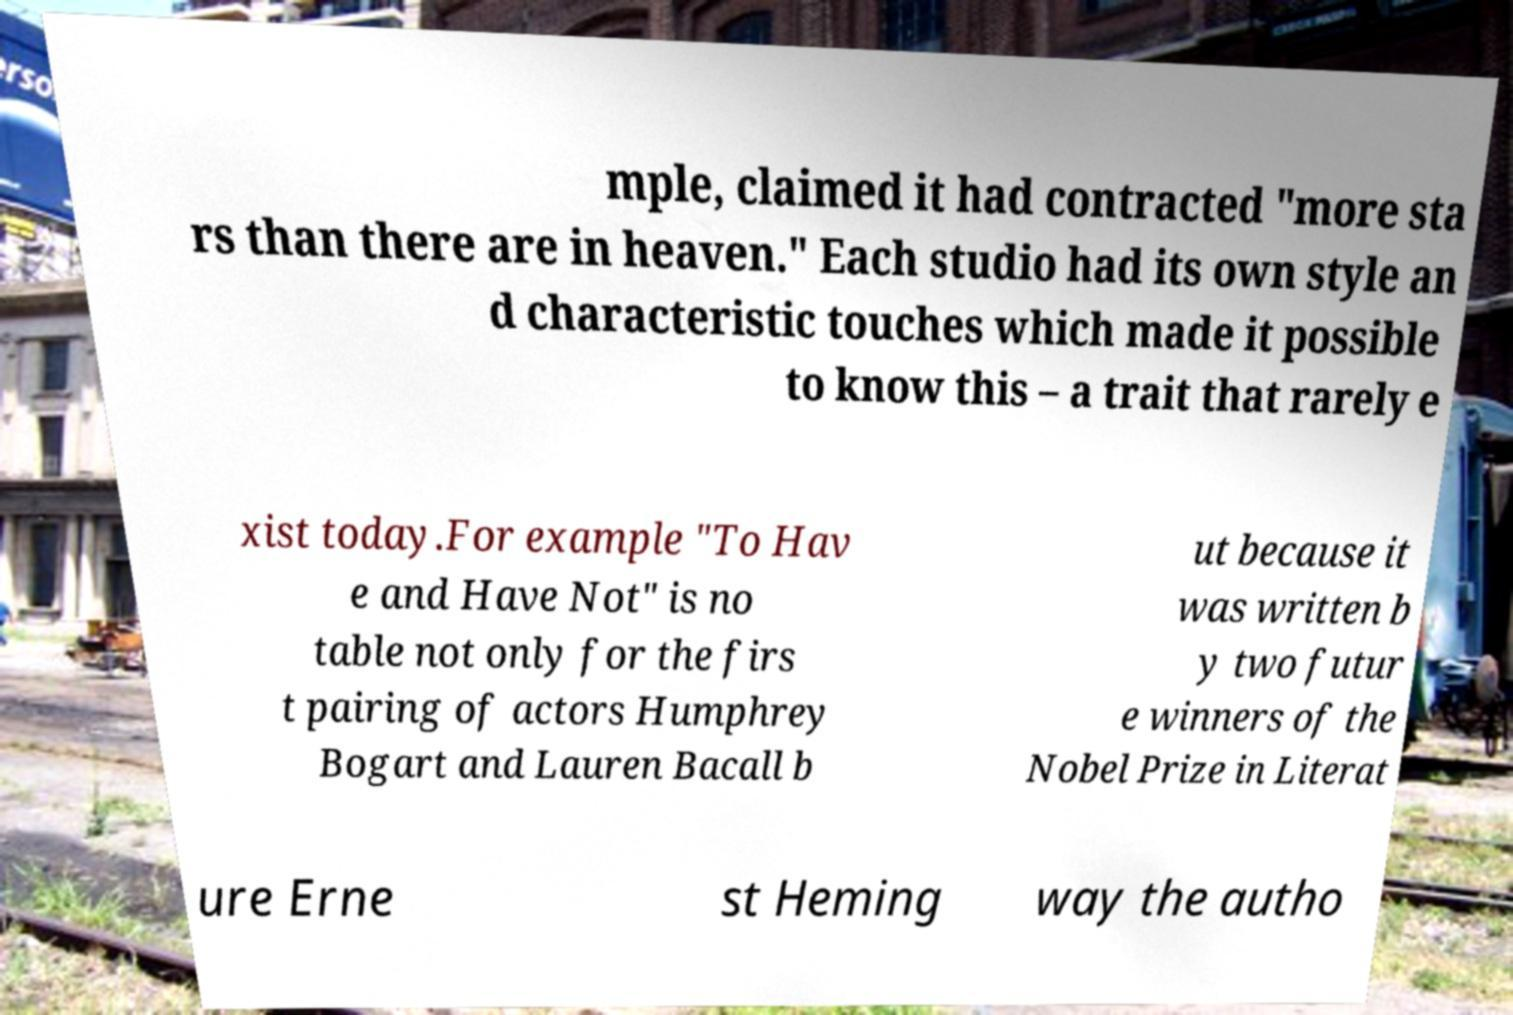Can you accurately transcribe the text from the provided image for me? mple, claimed it had contracted "more sta rs than there are in heaven." Each studio had its own style an d characteristic touches which made it possible to know this – a trait that rarely e xist today.For example "To Hav e and Have Not" is no table not only for the firs t pairing of actors Humphrey Bogart and Lauren Bacall b ut because it was written b y two futur e winners of the Nobel Prize in Literat ure Erne st Heming way the autho 